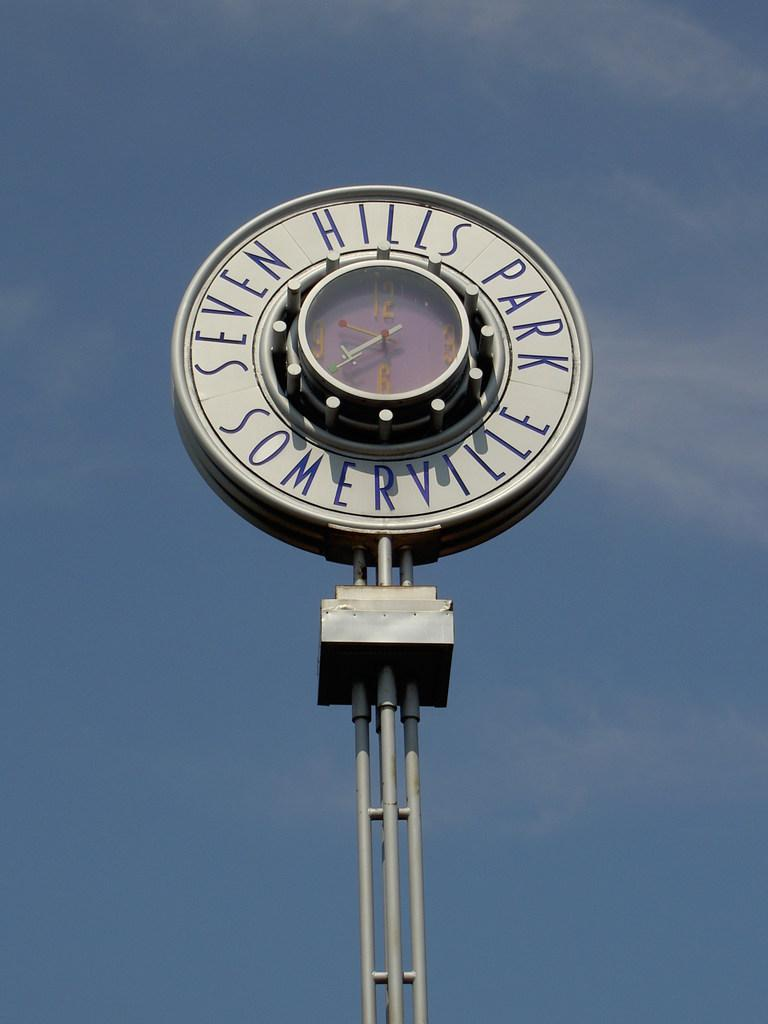<image>
Relay a brief, clear account of the picture shown. A clock from the Seven Hills Park in Somerville is shown on a mostly clear day. 